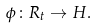<formula> <loc_0><loc_0><loc_500><loc_500>\phi \colon R _ { t } \to H .</formula> 